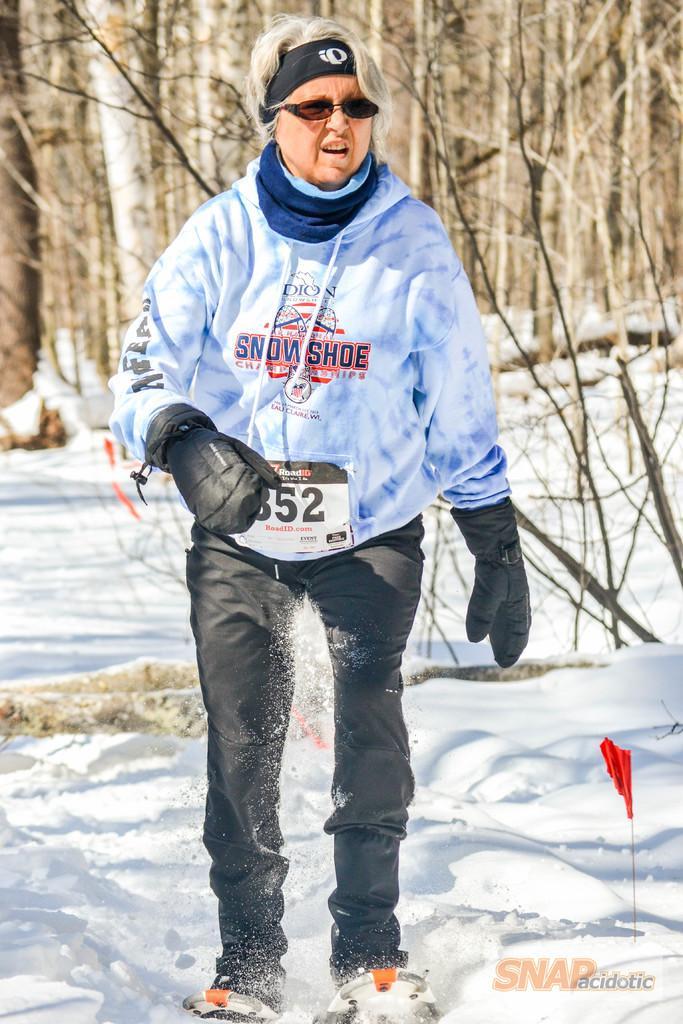How would you summarize this image in a sentence or two? In this picture we can see a woman standing on the ski boards. She wear a blue color jacket and gloves to her hands. She has goggles. And this is snow. And in the background we can see some trees. 